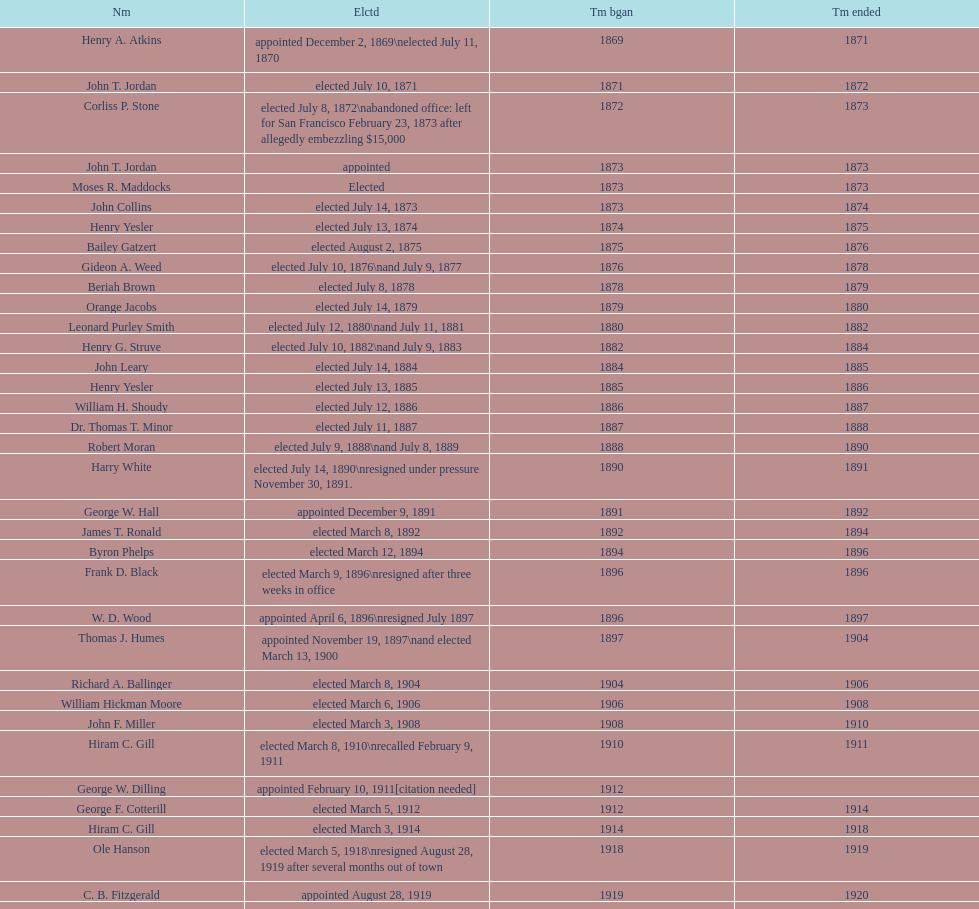Who was mayor of seattle, washington before being appointed to department of transportation during the nixon administration? James d'Orma Braman. 